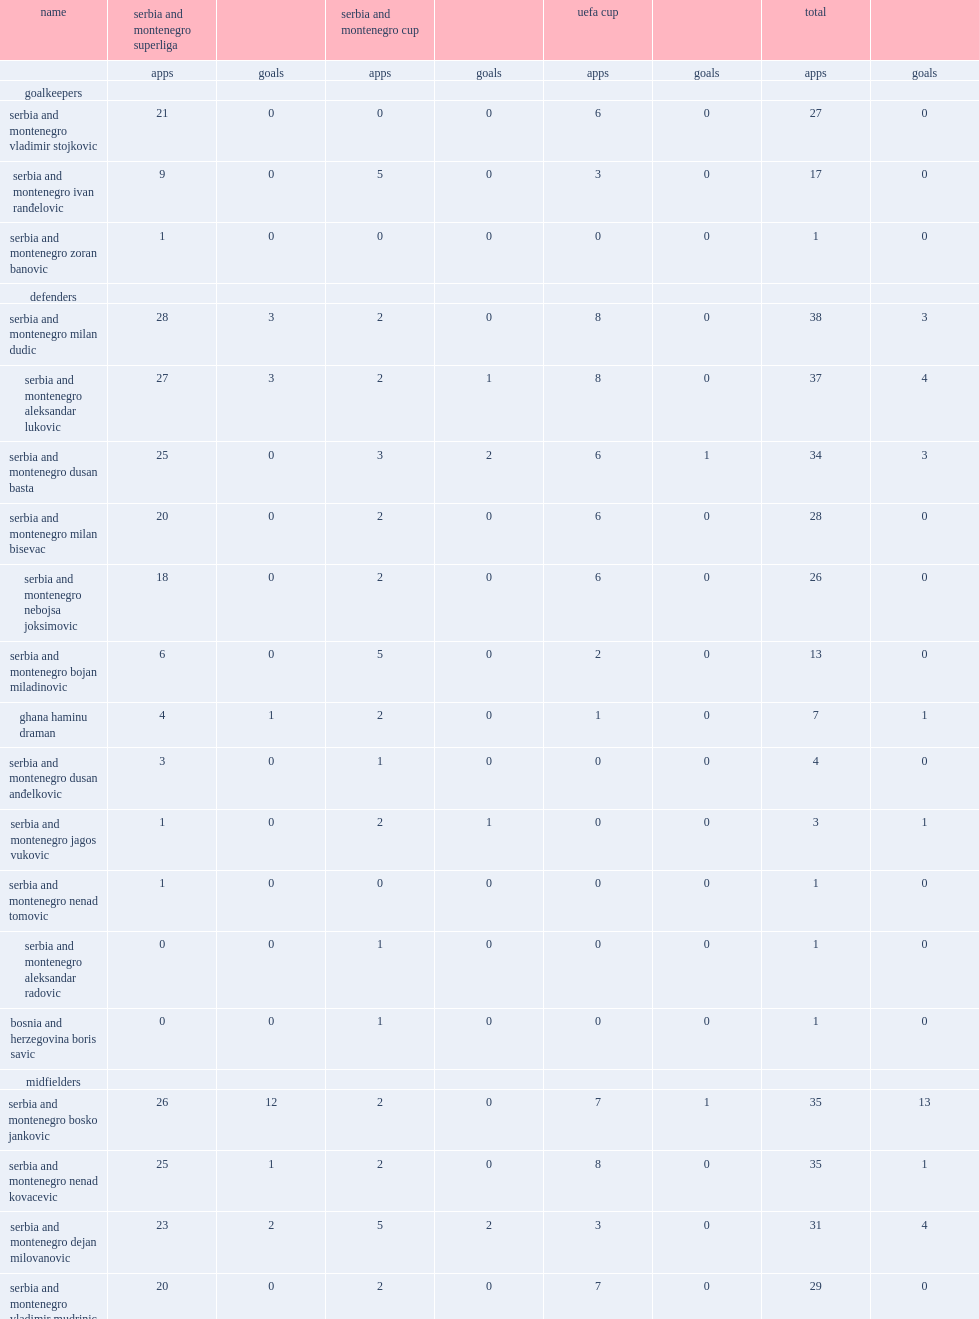What the matches did red star belgrade participate in? Serbia and montenegro superliga serbia and montenegro cup uefa cup. 